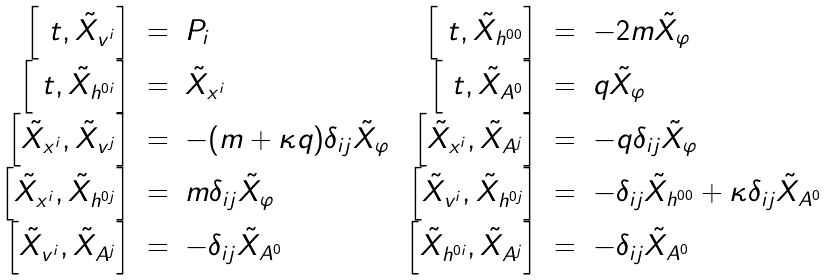Convert formula to latex. <formula><loc_0><loc_0><loc_500><loc_500>\begin{array} { r c l r c l } \left [ \ t , \tilde { X } _ { v ^ { i } } \right ] & = & P _ { i } & \left [ \ t , \tilde { X } _ { h ^ { 0 0 } } \right ] & = & - 2 m \tilde { X } _ { \varphi } \\ \left [ \ t , \tilde { X } _ { h ^ { 0 i } } \right ] & = & \tilde { X } _ { x ^ { i } } & \left [ \ t , \tilde { X } _ { A ^ { 0 } } \right ] & = & q \tilde { X } _ { \varphi } \\ \left [ \tilde { X } _ { x ^ { i } } , \tilde { X } _ { v ^ { j } } \right ] & = & - ( m + \kappa q ) \delta _ { i j } \tilde { X } _ { \varphi } & \left [ \tilde { X } _ { x ^ { i } } , \tilde { X } _ { A ^ { j } } \right ] & = & - q \delta _ { i j } \tilde { X } _ { \varphi } \\ \left [ \tilde { X } _ { x ^ { i } } , \tilde { X } _ { h ^ { 0 j } } \right ] & = & m \delta _ { i j } \tilde { X } _ { \varphi } & \left [ \tilde { X } _ { v ^ { i } } , \tilde { X } _ { h ^ { 0 j } } \right ] & = & - \delta _ { i j } \tilde { X } _ { h ^ { 0 0 } } + \kappa \delta _ { i j } \tilde { X } _ { A ^ { 0 } } \\ \left [ \tilde { X } _ { v ^ { i } } , \tilde { X } _ { A ^ { j } } \right ] & = & - \delta _ { i j } \tilde { X } _ { A ^ { 0 } } & \left [ \tilde { X } _ { h ^ { 0 i } } , \tilde { X } _ { A ^ { j } } \right ] & = & - \delta _ { i j } \tilde { X } _ { A ^ { 0 } } \end{array}</formula> 